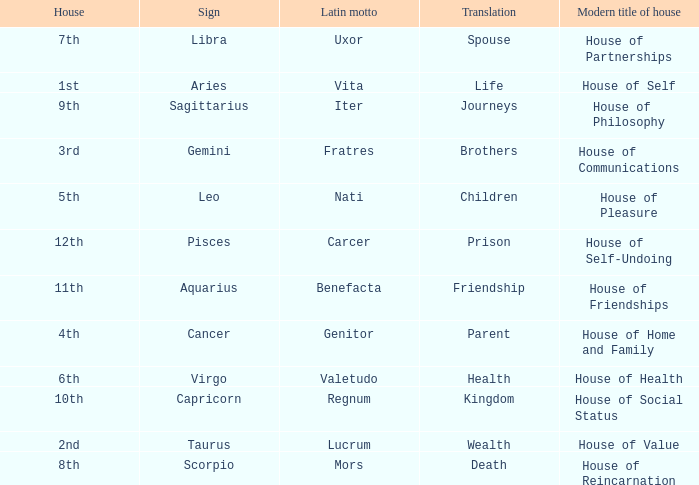Which sign has a modern house title of House of Partnerships? Libra. Can you parse all the data within this table? {'header': ['House', 'Sign', 'Latin motto', 'Translation', 'Modern title of house'], 'rows': [['7th', 'Libra', 'Uxor', 'Spouse', 'House of Partnerships'], ['1st', 'Aries', 'Vita', 'Life', 'House of Self'], ['9th', 'Sagittarius', 'Iter', 'Journeys', 'House of Philosophy'], ['3rd', 'Gemini', 'Fratres', 'Brothers', 'House of Communications'], ['5th', 'Leo', 'Nati', 'Children', 'House of Pleasure'], ['12th', 'Pisces', 'Carcer', 'Prison', 'House of Self-Undoing'], ['11th', 'Aquarius', 'Benefacta', 'Friendship', 'House of Friendships'], ['4th', 'Cancer', 'Genitor', 'Parent', 'House of Home and Family'], ['6th', 'Virgo', 'Valetudo', 'Health', 'House of Health'], ['10th', 'Capricorn', 'Regnum', 'Kingdom', 'House of Social Status'], ['2nd', 'Taurus', 'Lucrum', 'Wealth', 'House of Value'], ['8th', 'Scorpio', 'Mors', 'Death', 'House of Reincarnation']]} 